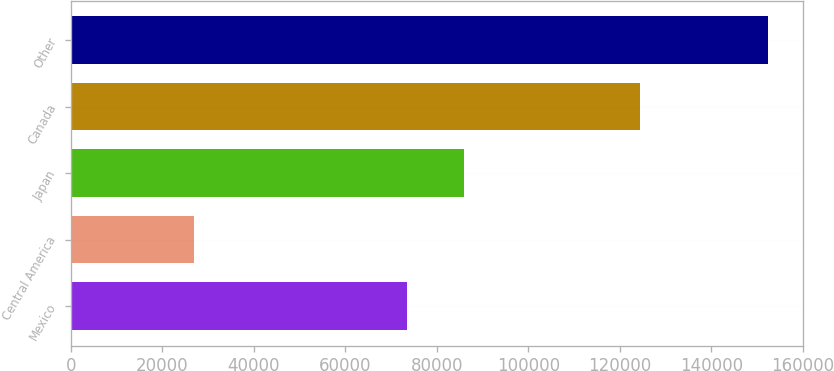Convert chart. <chart><loc_0><loc_0><loc_500><loc_500><bar_chart><fcel>Mexico<fcel>Central America<fcel>Japan<fcel>Canada<fcel>Other<nl><fcel>73427<fcel>26851<fcel>85983.4<fcel>124500<fcel>152415<nl></chart> 